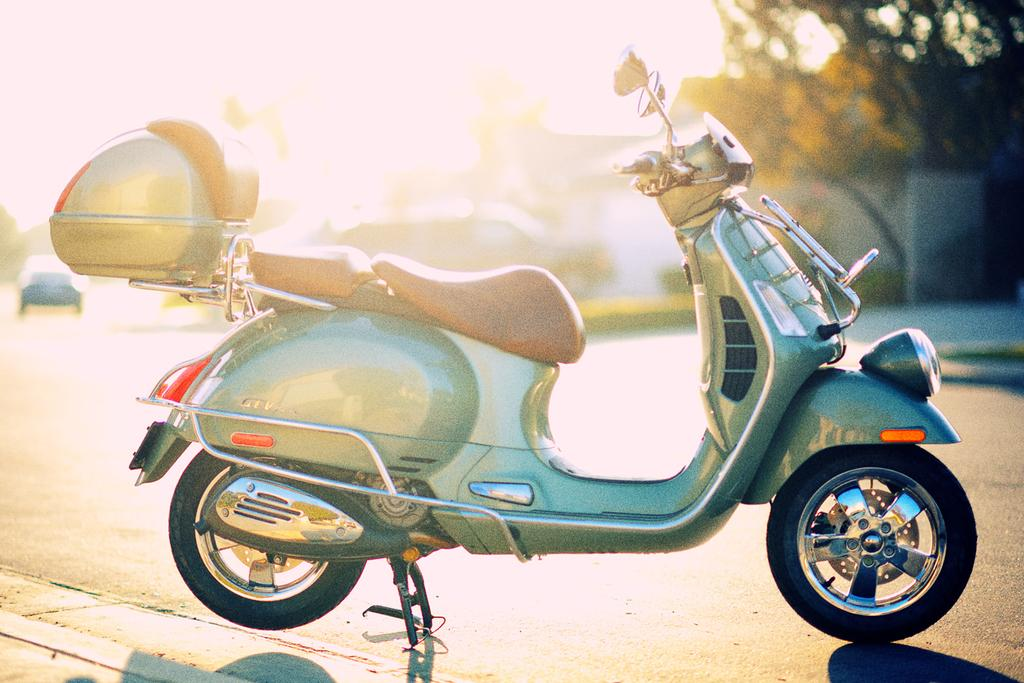What type of vehicle is parked on the side of the road in the image? There is a scooter parked on the side of the road in the image. What can be seen in the background of the image? Trees are visible in the image. What is happening on the road in the image? A car is moving on the road in the image. What is attached to the scooter on the back? There is a box attached to the scooter on the back. What story is being told by the trees in the image? The trees in the image are not telling a story; they are simply part of the background. 